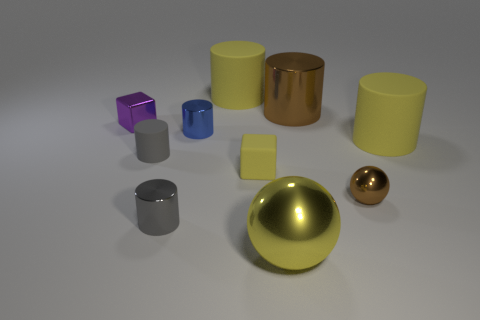Subtract all yellow cylinders. How many cylinders are left? 4 Subtract all brown spheres. How many spheres are left? 1 Subtract 0 purple spheres. How many objects are left? 10 Subtract all balls. How many objects are left? 8 Subtract 2 spheres. How many spheres are left? 0 Subtract all yellow blocks. Subtract all yellow cylinders. How many blocks are left? 1 Subtract all red cylinders. How many gray balls are left? 0 Subtract all big red rubber objects. Subtract all brown metallic things. How many objects are left? 8 Add 8 small brown spheres. How many small brown spheres are left? 9 Add 3 large metal cylinders. How many large metal cylinders exist? 4 